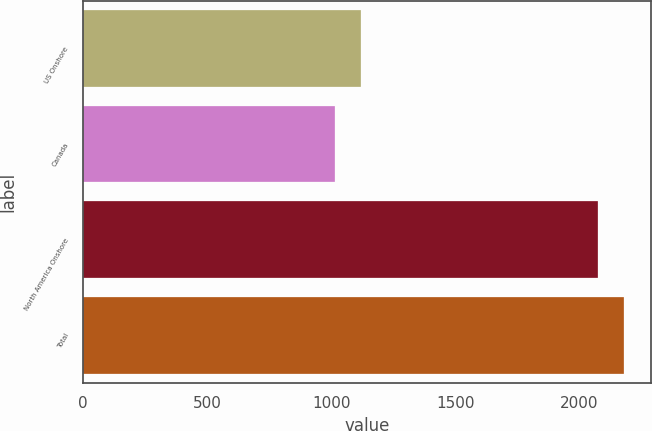<chart> <loc_0><loc_0><loc_500><loc_500><bar_chart><fcel>US Onshore<fcel>Canada<fcel>North America Onshore<fcel>Total<nl><fcel>1120.9<fcel>1015<fcel>2074<fcel>2179.9<nl></chart> 